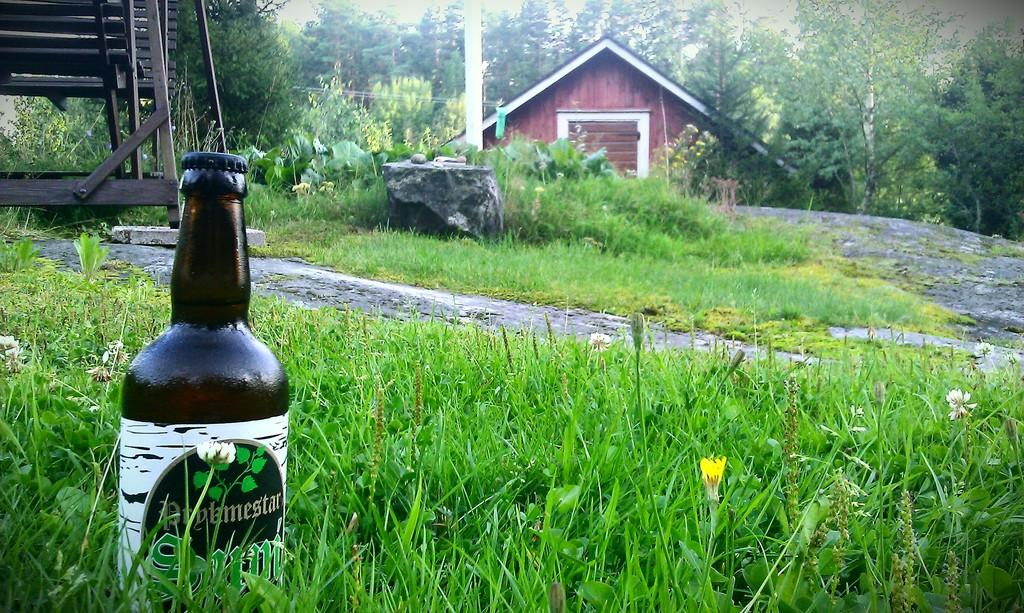What is the main object in the image? There is a wine bottle in the image. Where is the wine bottle located? The wine bottle is on the grass. What can be seen in the background of the image? There is a house in the background of the image, and many trees behind the house. Is the wine bottle producing steam in the image? No, the wine bottle is not producing steam in the image. 